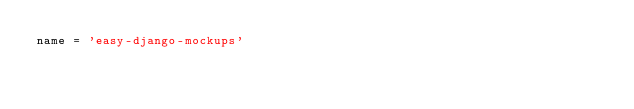<code> <loc_0><loc_0><loc_500><loc_500><_Python_>name = 'easy-django-mockups'</code> 